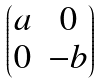<formula> <loc_0><loc_0><loc_500><loc_500>\begin{pmatrix} a & 0 \\ 0 & - b \end{pmatrix}</formula> 